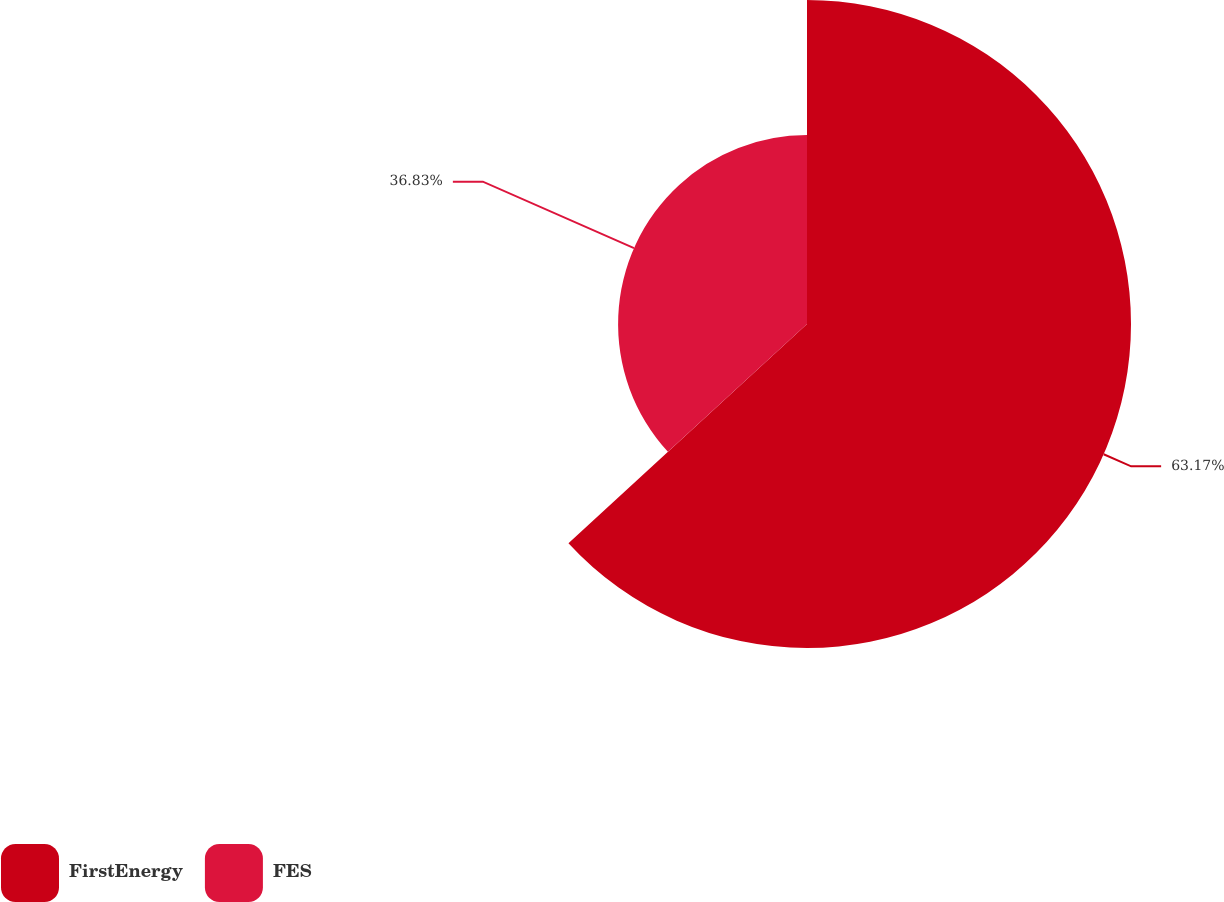<chart> <loc_0><loc_0><loc_500><loc_500><pie_chart><fcel>FirstEnergy<fcel>FES<nl><fcel>63.17%<fcel>36.83%<nl></chart> 